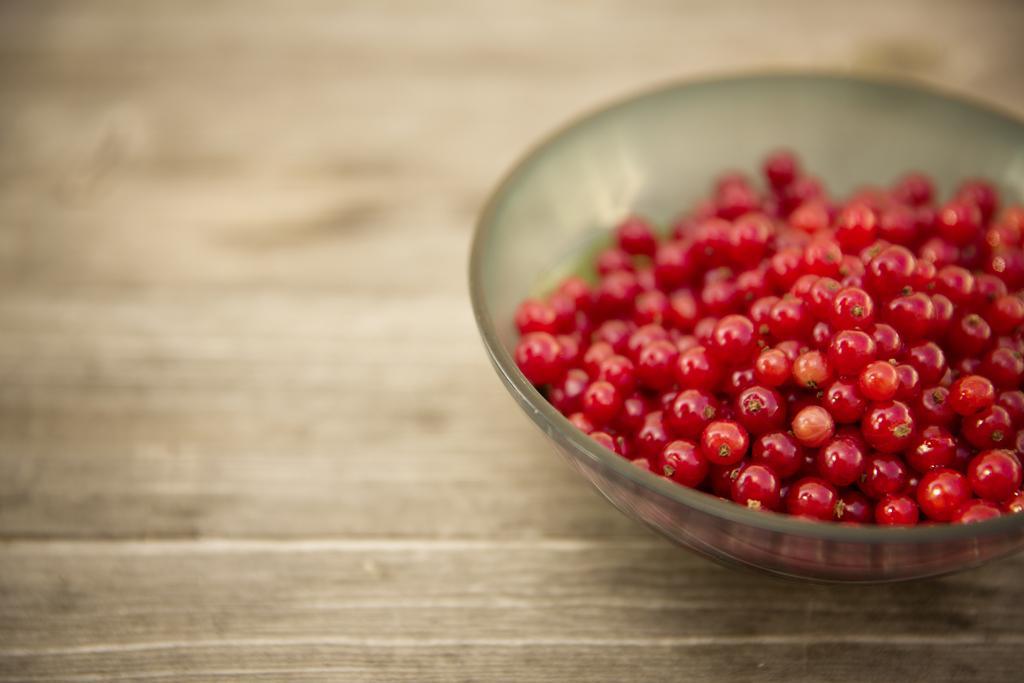Describe this image in one or two sentences. On the right of this picture we can see a bowl containing the red color food items which seems to be the berries and the bowl is placed on the top of the wooden table. 